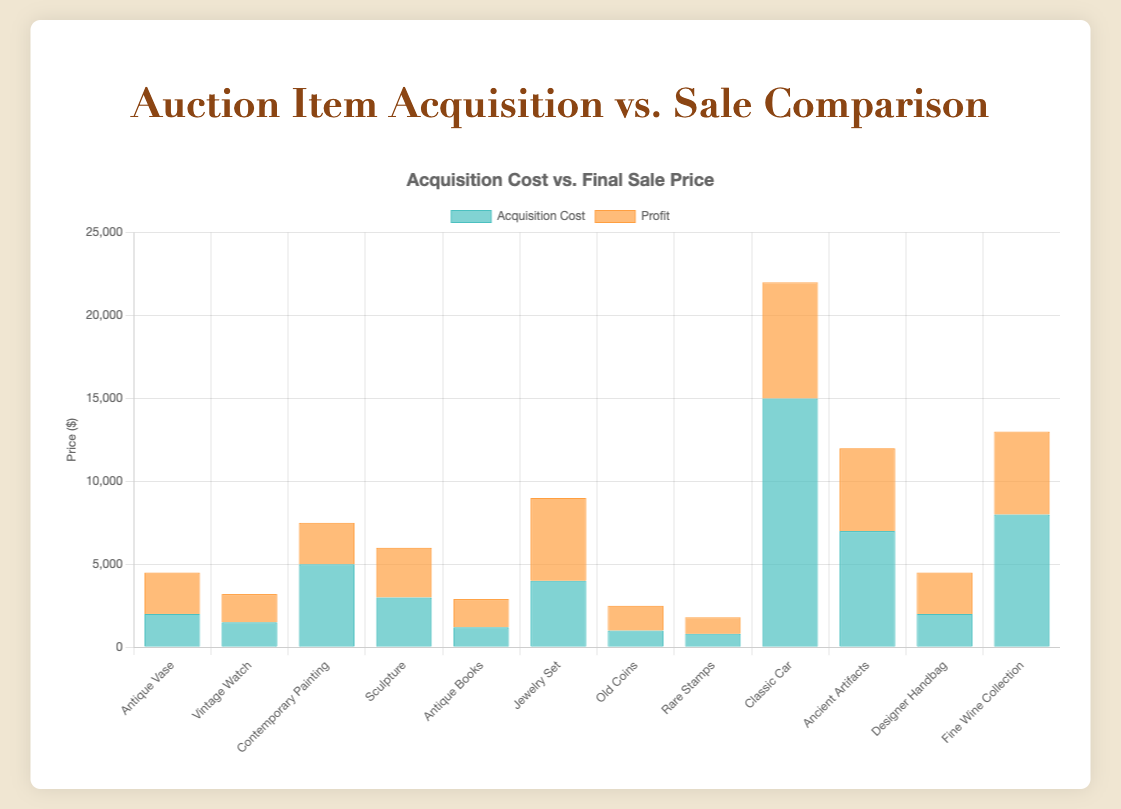Which item produced the highest profit? To identify the item with the highest profit, look at the "Profit" segment in the bars. The Jewelry Set has the highest segment visually.
Answer: Jewelry Set Which acquisition source had the highest total final sale price? To find this, sum the final sale prices for each acquisition source and compare them. Estate Sale: 4500 + 6000 + 2500 + 12000 = 25000, Direct Seller: 3200 + 2900 + 1800 + 4500 = 12400, Consignment: 7500 + 9000 + 22000 + 13000 = 51500. Consignment has the highest.
Answer: Consignment What is the total acquisition cost for items acquired from estate sales? Sum acquisition costs for items with the acquisition source "Estate Sale." 2000 + 3000 + 1000 + 7000 = 13000
Answer: 13000 What's the average difference between acquisition cost and final sale price for items acquired from direct sellers? Calculate the difference for each item from direct sellers and find the average: (3200-1500) + (2900-1200) + (1800-800) + (4500-2000) = 3700. Average is 3700/4 = 925.
Answer: 925 Which item from consignment has the lowest profit? Check the "Profit" segment for each consigned item and find the smallest. The Contemporary Painting (7500-5000=2500) has the smallest profit visually.
Answer: Contemporary Painting Compare the acquisition cost of the Classic Car to the final sale price of the Fine Wine Collection. Which is higher? Look at both values: Classic Car acquisition cost is 15000, Fine Wine Collection's final sale price is 13000.
Answer: Classic Car How does the average final sale price of items from estate sales compare to direct sellers? Calculate average final sale price for each: Estate Sale (4500+6000+2500+12000)/4 = 6250, Direct Seller (3200+2900+1800+4500)/4 = 3100. 6250 > 3100
Answer: Estate sales have higher average final sale price What's the overall profit of all items acquired via consignment? Sum the individual profits: (7500-5000) + (9000-4000) + (22000-15000) + (13000-8000) = 2500 + 5000 + 7000 + 5000 = 19500
Answer: 19500 